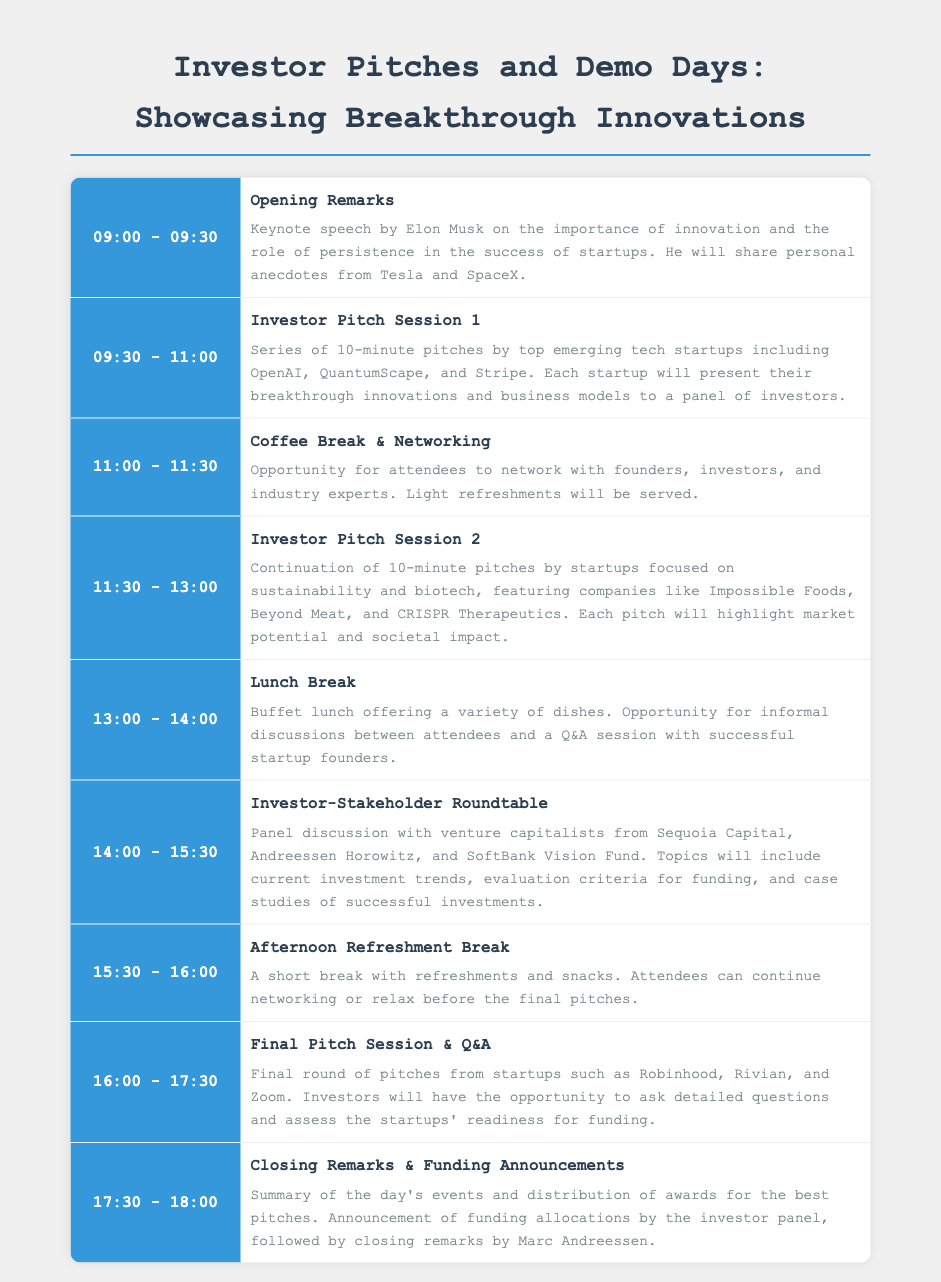What time does the opening remarks start? The opening remarks begin at 09:00.
Answer: 09:00 Who is giving the keynote speech? The keynote speech is given by Elon Musk.
Answer: Elon Musk How many startups are pitching in Investor Pitch Session 1? The session includes a series of pitches, specifically mentioning several startups, which implies more than one. The document states "10-minute pitches by top emerging tech startups" indicating ten startups.
Answer: 10 What companies are featured in Investor Pitch Session 2? The session features startups like Impossible Foods, Beyond Meat, and CRISPR Therapeutics.
Answer: Impossible Foods, Beyond Meat, CRISPR Therapeutics What is the main focus of the Investor-Stakeholder Roundtable? The main topics discussed will include current investment trends and evaluation criteria for funding.
Answer: Investment trends What time does the final pitch session end? The final pitch session is scheduled to end at 17:30.
Answer: 17:30 Who will announce the funding allocations? The funding allocations will be announced by the investor panel.
Answer: Investor panel What is the duration of the coffee break? The coffee break lasts for 30 minutes, from 11:00 to 11:30.
Answer: 30 minutes 